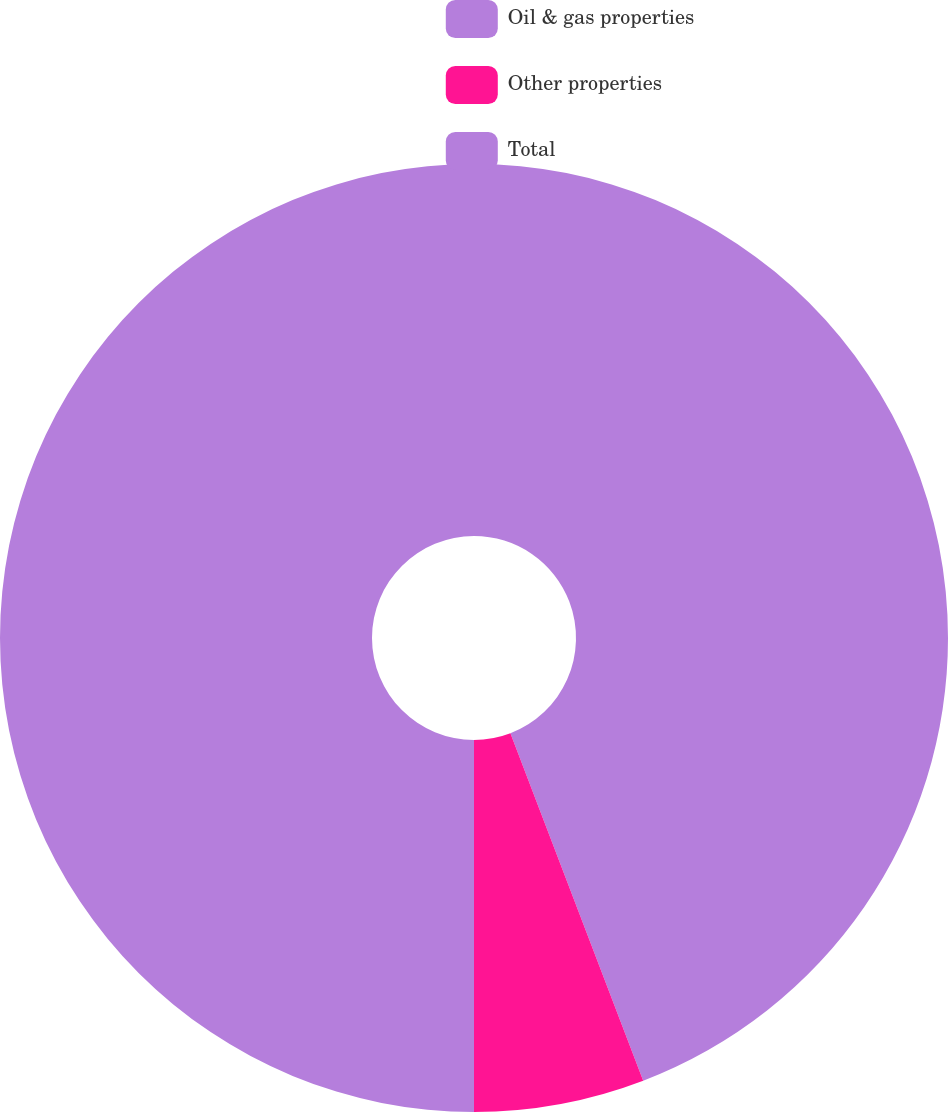<chart> <loc_0><loc_0><loc_500><loc_500><pie_chart><fcel>Oil & gas properties<fcel>Other properties<fcel>Total<nl><fcel>44.19%<fcel>5.81%<fcel>50.0%<nl></chart> 